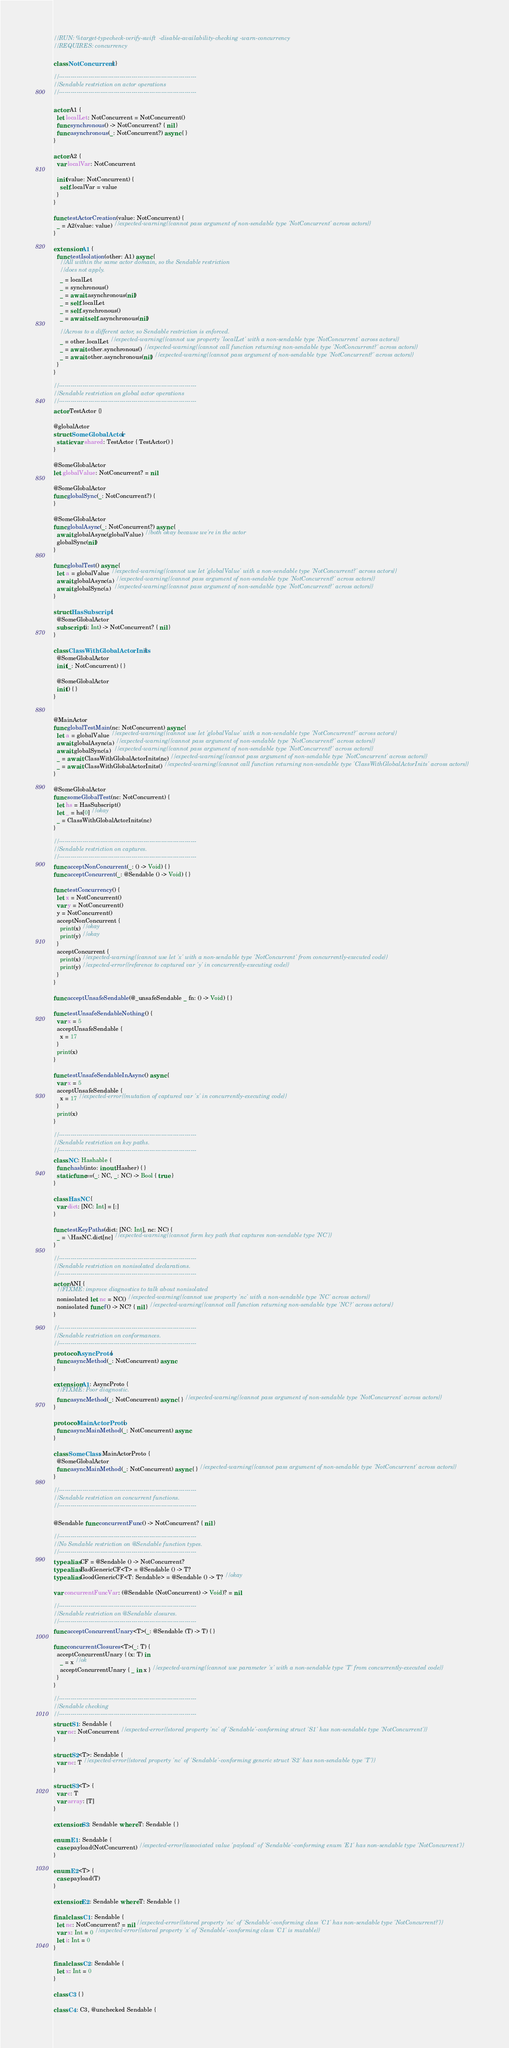<code> <loc_0><loc_0><loc_500><loc_500><_Swift_>// RUN: %target-typecheck-verify-swift  -disable-availability-checking -warn-concurrency
// REQUIRES: concurrency

class NotConcurrent { }

// ----------------------------------------------------------------------
// Sendable restriction on actor operations
// ----------------------------------------------------------------------

actor A1 {
  let localLet: NotConcurrent = NotConcurrent()
  func synchronous() -> NotConcurrent? { nil }
  func asynchronous(_: NotConcurrent?) async { }
}

actor A2 {
  var localVar: NotConcurrent

  init(value: NotConcurrent) {
    self.localVar = value
  }
}

func testActorCreation(value: NotConcurrent) {
  _ = A2(value: value) // expected-warning{{cannot pass argument of non-sendable type 'NotConcurrent' across actors}}
}

extension A1 {
  func testIsolation(other: A1) async {
    // All within the same actor domain, so the Sendable restriction
    // does not apply.
    _ = localLet
    _ = synchronous()
    _ = await asynchronous(nil)
    _ = self.localLet
    _ = self.synchronous()
    _ = await self.asynchronous(nil)

    // Across to a different actor, so Sendable restriction is enforced.
    _ = other.localLet // expected-warning{{cannot use property 'localLet' with a non-sendable type 'NotConcurrent' across actors}}
    _ = await other.synchronous() // expected-warning{{cannot call function returning non-sendable type 'NotConcurrent?' across actors}}
    _ = await other.asynchronous(nil) // expected-warning{{cannot pass argument of non-sendable type 'NotConcurrent?' across actors}}
  }
}

// ----------------------------------------------------------------------
// Sendable restriction on global actor operations
// ----------------------------------------------------------------------
actor TestActor {}

@globalActor
struct SomeGlobalActor {
  static var shared: TestActor { TestActor() }
}

@SomeGlobalActor
let globalValue: NotConcurrent? = nil

@SomeGlobalActor
func globalSync(_: NotConcurrent?) {
}

@SomeGlobalActor
func globalAsync(_: NotConcurrent?) async {
  await globalAsync(globalValue) // both okay because we're in the actor
  globalSync(nil)
}

func globalTest() async {
  let a = globalValue // expected-warning{{cannot use let 'globalValue' with a non-sendable type 'NotConcurrent?' across actors}}
  await globalAsync(a) // expected-warning{{cannot pass argument of non-sendable type 'NotConcurrent?' across actors}}
  await globalSync(a)  // expected-warning{{cannot pass argument of non-sendable type 'NotConcurrent?' across actors}}
}

struct HasSubscript {
  @SomeGlobalActor
  subscript (i: Int) -> NotConcurrent? { nil }
}

class ClassWithGlobalActorInits {
  @SomeGlobalActor
  init(_: NotConcurrent) { }

  @SomeGlobalActor
  init() { }
}


@MainActor
func globalTestMain(nc: NotConcurrent) async {
  let a = globalValue // expected-warning{{cannot use let 'globalValue' with a non-sendable type 'NotConcurrent?' across actors}}
  await globalAsync(a) // expected-warning{{cannot pass argument of non-sendable type 'NotConcurrent?' across actors}}
  await globalSync(a)  // expected-warning{{cannot pass argument of non-sendable type 'NotConcurrent?' across actors}}
  _ = await ClassWithGlobalActorInits(nc) // expected-warning{{cannot pass argument of non-sendable type 'NotConcurrent' across actors}}
  _ = await ClassWithGlobalActorInits() // expected-warning{{cannot call function returning non-sendable type 'ClassWithGlobalActorInits' across actors}}
}

@SomeGlobalActor
func someGlobalTest(nc: NotConcurrent) {
  let hs = HasSubscript()
  let _ = hs[0] // okay
  _ = ClassWithGlobalActorInits(nc)
}

// ----------------------------------------------------------------------
// Sendable restriction on captures.
// ----------------------------------------------------------------------
func acceptNonConcurrent(_: () -> Void) { }
func acceptConcurrent(_: @Sendable () -> Void) { }

func testConcurrency() {
  let x = NotConcurrent()
  var y = NotConcurrent()
  y = NotConcurrent()
  acceptNonConcurrent {
    print(x) // okay
    print(y) // okay
  }
  acceptConcurrent {
    print(x) // expected-warning{{cannot use let 'x' with a non-sendable type 'NotConcurrent' from concurrently-executed code}}
    print(y) // expected-error{{reference to captured var 'y' in concurrently-executing code}}
  }
}

func acceptUnsafeSendable(@_unsafeSendable _ fn: () -> Void) { }

func testUnsafeSendableNothing() {
  var x = 5
  acceptUnsafeSendable {
    x = 17
  }
  print(x)
}

func testUnsafeSendableInAsync() async {
  var x = 5
  acceptUnsafeSendable {
    x = 17 // expected-error{{mutation of captured var 'x' in concurrently-executing code}}
  }
  print(x)
}

// ----------------------------------------------------------------------
// Sendable restriction on key paths.
// ----------------------------------------------------------------------
class NC: Hashable {
  func hash(into: inout Hasher) { }
  static func==(_: NC, _: NC) -> Bool { true }
}

class HasNC {
  var dict: [NC: Int] = [:]
}

func testKeyPaths(dict: [NC: Int], nc: NC) {
  _ = \HasNC.dict[nc] // expected-warning{{cannot form key path that captures non-sendable type 'NC'}}
}

// ----------------------------------------------------------------------
// Sendable restriction on nonisolated declarations.
// ----------------------------------------------------------------------
actor ANI {
  // FIXME: improve diagnostics to talk about nonisolated
  nonisolated let nc = NC() // expected-warning{{cannot use property 'nc' with a non-sendable type 'NC' across actors}}
  nonisolated func f() -> NC? { nil } // expected-warning{{cannot call function returning non-sendable type 'NC?' across actors}}
}

// ----------------------------------------------------------------------
// Sendable restriction on conformances.
// ----------------------------------------------------------------------
protocol AsyncProto {
  func asyncMethod(_: NotConcurrent) async
}

extension A1: AsyncProto {
  // FIXME: Poor diagnostic.
  func asyncMethod(_: NotConcurrent) async { } // expected-warning{{cannot pass argument of non-sendable type 'NotConcurrent' across actors}}
}

protocol MainActorProto {
  func asyncMainMethod(_: NotConcurrent) async
}

class SomeClass: MainActorProto {
  @SomeGlobalActor
  func asyncMainMethod(_: NotConcurrent) async { } // expected-warning{{cannot pass argument of non-sendable type 'NotConcurrent' across actors}}
}

// ----------------------------------------------------------------------
// Sendable restriction on concurrent functions.
// ----------------------------------------------------------------------

@Sendable func concurrentFunc() -> NotConcurrent? { nil }

// ----------------------------------------------------------------------
// No Sendable restriction on @Sendable function types.
// ----------------------------------------------------------------------
typealias CF = @Sendable () -> NotConcurrent?
typealias BadGenericCF<T> = @Sendable () -> T?
typealias GoodGenericCF<T: Sendable> = @Sendable () -> T? // okay

var concurrentFuncVar: (@Sendable (NotConcurrent) -> Void)? = nil

// ----------------------------------------------------------------------
// Sendable restriction on @Sendable closures.
// ----------------------------------------------------------------------
func acceptConcurrentUnary<T>(_: @Sendable (T) -> T) { }

func concurrentClosures<T>(_: T) {
  acceptConcurrentUnary { (x: T) in
    _ = x // ok
    acceptConcurrentUnary { _ in x } // expected-warning{{cannot use parameter 'x' with a non-sendable type 'T' from concurrently-executed code}}
  }
}

// ----------------------------------------------------------------------
// Sendable checking
// ----------------------------------------------------------------------
struct S1: Sendable {
  var nc: NotConcurrent // expected-error{{stored property 'nc' of 'Sendable'-conforming struct 'S1' has non-sendable type 'NotConcurrent'}}
}

struct S2<T>: Sendable {
  var nc: T // expected-error{{stored property 'nc' of 'Sendable'-conforming generic struct 'S2' has non-sendable type 'T'}}
}

struct S3<T> {
  var c: T
  var array: [T]
}

extension S3: Sendable where T: Sendable { }

enum E1: Sendable {
  case payload(NotConcurrent) // expected-error{{associated value 'payload' of 'Sendable'-conforming enum 'E1' has non-sendable type 'NotConcurrent'}}
}

enum E2<T> {
  case payload(T)
}

extension E2: Sendable where T: Sendable { }

final class C1: Sendable {
  let nc: NotConcurrent? = nil // expected-error{{stored property 'nc' of 'Sendable'-conforming class 'C1' has non-sendable type 'NotConcurrent?'}}
  var x: Int = 0 // expected-error{{stored property 'x' of 'Sendable'-conforming class 'C1' is mutable}}
  let i: Int = 0
}

final class C2: Sendable {
  let x: Int = 0
}

class C3 { }

class C4: C3, @unchecked Sendable {</code> 